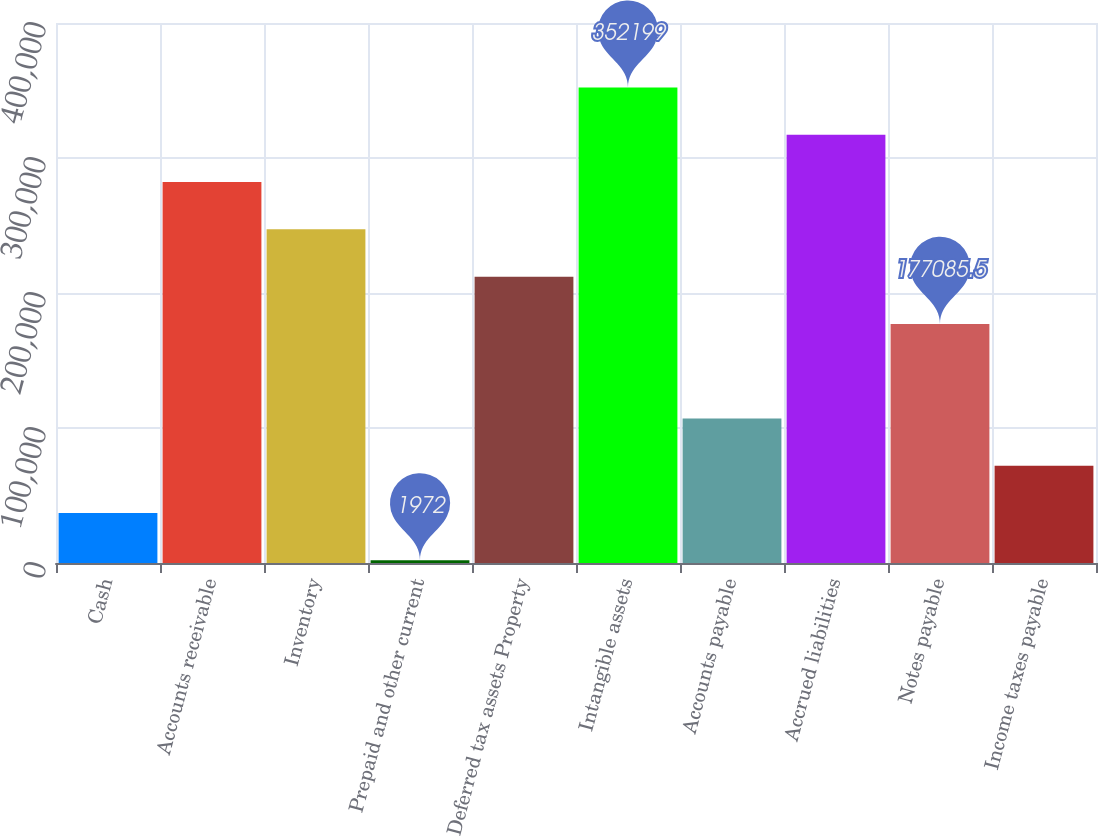<chart> <loc_0><loc_0><loc_500><loc_500><bar_chart><fcel>Cash<fcel>Accounts receivable<fcel>Inventory<fcel>Prepaid and other current<fcel>Deferred tax assets Property<fcel>Intangible assets<fcel>Accounts payable<fcel>Accrued liabilities<fcel>Notes payable<fcel>Income taxes payable<nl><fcel>36994.7<fcel>282154<fcel>247131<fcel>1972<fcel>212108<fcel>352199<fcel>107040<fcel>317176<fcel>177086<fcel>72017.4<nl></chart> 